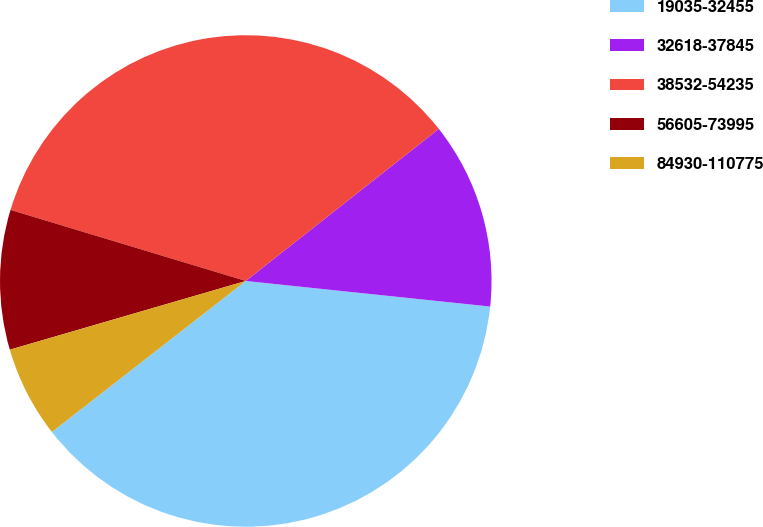Convert chart to OTSL. <chart><loc_0><loc_0><loc_500><loc_500><pie_chart><fcel>19035-32455<fcel>32618-37845<fcel>38532-54235<fcel>56605-73995<fcel>84930-110775<nl><fcel>37.81%<fcel>12.28%<fcel>34.71%<fcel>9.18%<fcel>6.02%<nl></chart> 